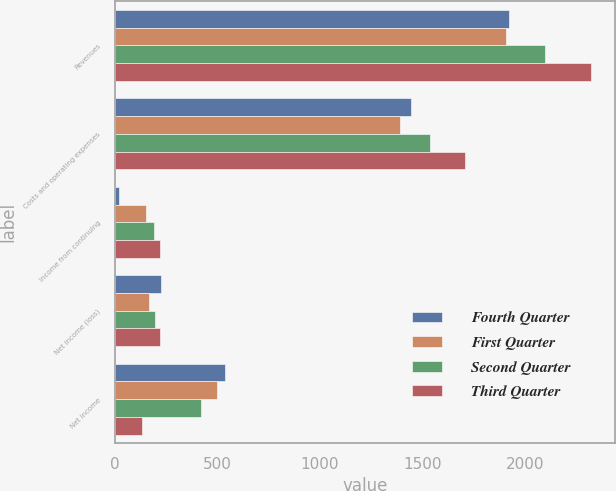<chart> <loc_0><loc_0><loc_500><loc_500><stacked_bar_chart><ecel><fcel>Revenues<fcel>Costs and operating expenses<fcel>Income from continuing<fcel>Net income (loss)<fcel>Net income<nl><fcel>Fourth Quarter<fcel>1922<fcel>1444<fcel>19<fcel>224<fcel>539<nl><fcel>First Quarter<fcel>1909<fcel>1392<fcel>151<fcel>169<fcel>500<nl><fcel>Second Quarter<fcel>2098<fcel>1537<fcel>192<fcel>194<fcel>421<nl><fcel>Third Quarter<fcel>2326<fcel>1708<fcel>222<fcel>222<fcel>132<nl></chart> 